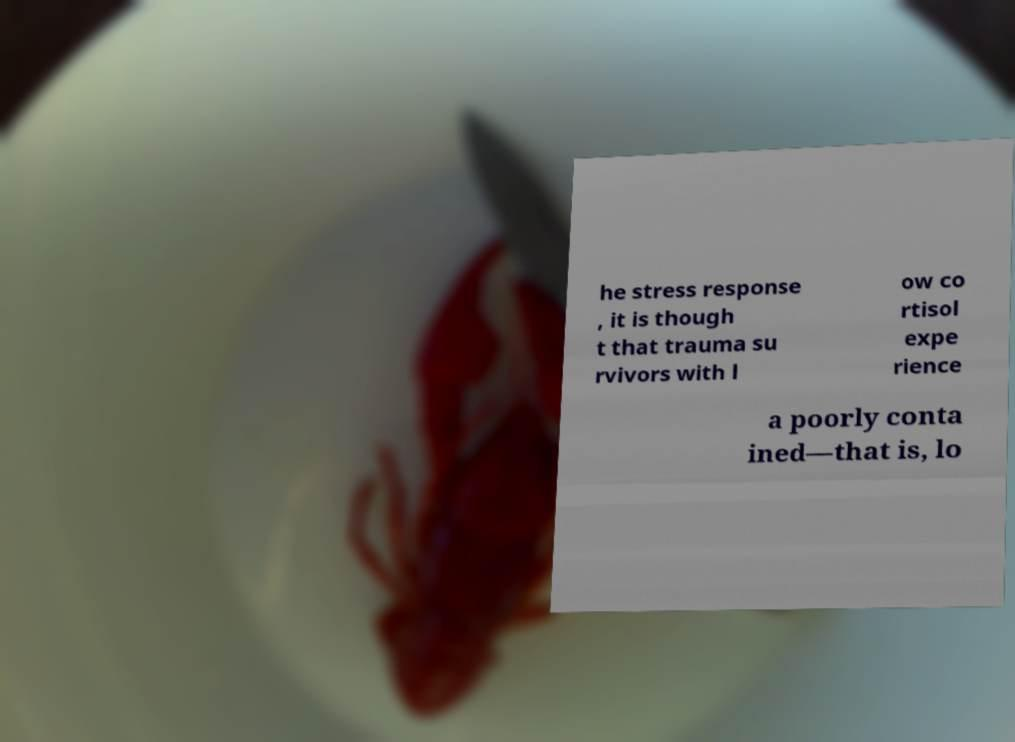For documentation purposes, I need the text within this image transcribed. Could you provide that? he stress response , it is though t that trauma su rvivors with l ow co rtisol expe rience a poorly conta ined—that is, lo 